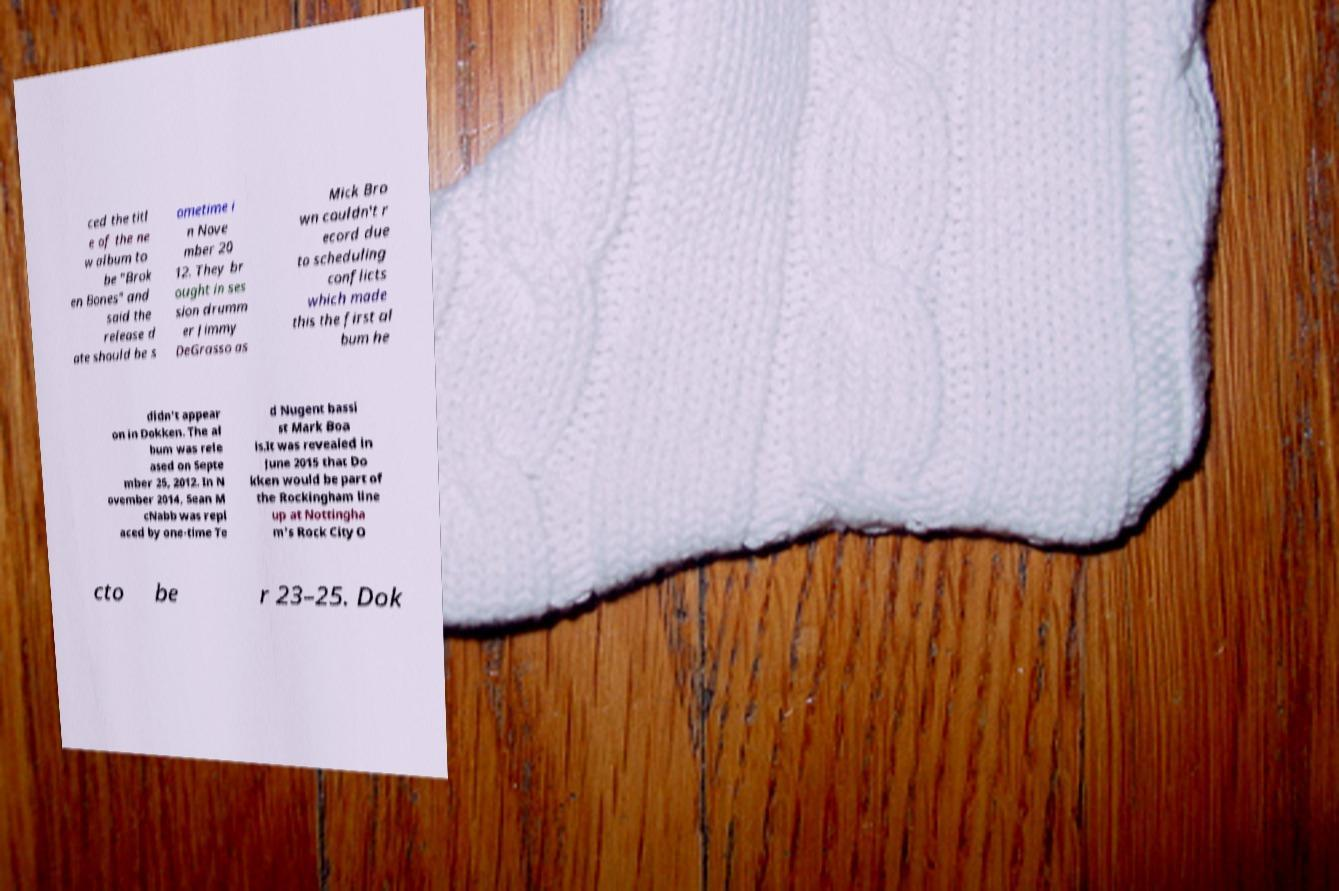For documentation purposes, I need the text within this image transcribed. Could you provide that? ced the titl e of the ne w album to be "Brok en Bones" and said the release d ate should be s ometime i n Nove mber 20 12. They br ought in ses sion drumm er Jimmy DeGrasso as Mick Bro wn couldn't r ecord due to scheduling conflicts which made this the first al bum he didn't appear on in Dokken. The al bum was rele ased on Septe mber 25, 2012. In N ovember 2014, Sean M cNabb was repl aced by one-time Te d Nugent bassi st Mark Boa ls.It was revealed in June 2015 that Do kken would be part of the Rockingham line up at Nottingha m's Rock City O cto be r 23–25. Dok 